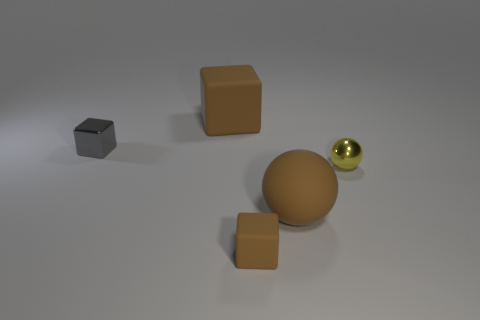There is a block that is on the left side of the brown rubber thing behind the small gray shiny thing; how big is it?
Your response must be concise. Small. What is the size of the brown sphere?
Provide a short and direct response. Large. The matte object that is behind the tiny brown thing and on the right side of the large brown cube has what shape?
Your response must be concise. Sphere. What color is the other big thing that is the same shape as the gray shiny object?
Make the answer very short. Brown. How many things are either shiny objects to the right of the tiny matte object or gray blocks to the left of the yellow metal ball?
Your response must be concise. 2. The small brown object is what shape?
Offer a very short reply. Cube. What shape is the small object that is the same color as the large sphere?
Your answer should be very brief. Cube. What number of tiny gray blocks have the same material as the yellow object?
Provide a short and direct response. 1. The large matte block is what color?
Keep it short and to the point. Brown. There is a rubber thing that is the same size as the gray cube; what color is it?
Offer a very short reply. Brown. 